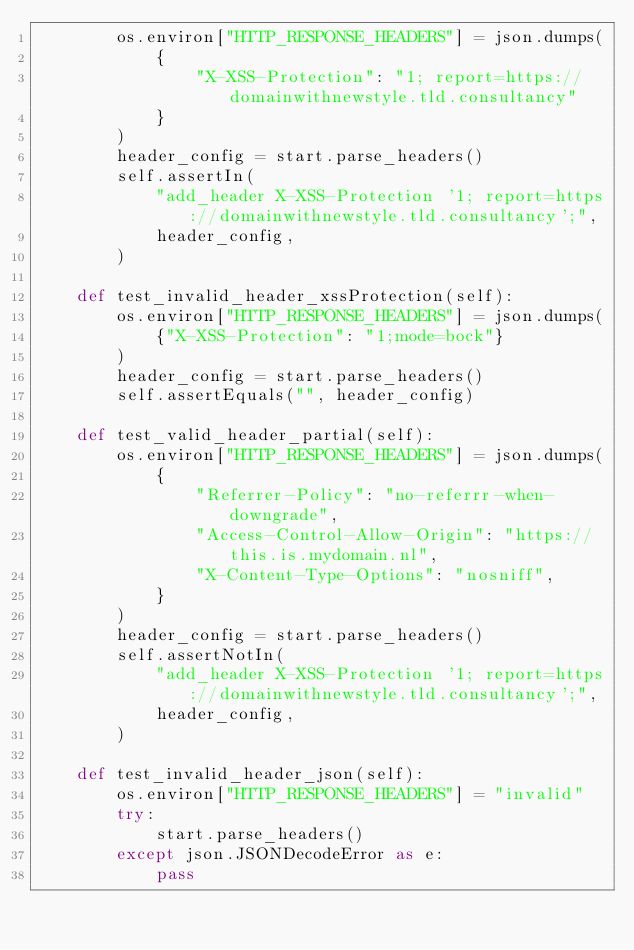Convert code to text. <code><loc_0><loc_0><loc_500><loc_500><_Python_>        os.environ["HTTP_RESPONSE_HEADERS"] = json.dumps(
            {
                "X-XSS-Protection": "1; report=https://domainwithnewstyle.tld.consultancy"
            }
        )
        header_config = start.parse_headers()
        self.assertIn(
            "add_header X-XSS-Protection '1; report=https://domainwithnewstyle.tld.consultancy';",
            header_config,
        )

    def test_invalid_header_xssProtection(self):
        os.environ["HTTP_RESPONSE_HEADERS"] = json.dumps(
            {"X-XSS-Protection": "1;mode=bock"}
        )
        header_config = start.parse_headers()
        self.assertEquals("", header_config)

    def test_valid_header_partial(self):
        os.environ["HTTP_RESPONSE_HEADERS"] = json.dumps(
            {
                "Referrer-Policy": "no-referrr-when-downgrade",
                "Access-Control-Allow-Origin": "https://this.is.mydomain.nl",
                "X-Content-Type-Options": "nosniff",
            }
        )
        header_config = start.parse_headers()
        self.assertNotIn(
            "add_header X-XSS-Protection '1; report=https://domainwithnewstyle.tld.consultancy';",
            header_config,
        )

    def test_invalid_header_json(self):
        os.environ["HTTP_RESPONSE_HEADERS"] = "invalid"
        try:
            start.parse_headers()
        except json.JSONDecodeError as e:
            pass
</code> 